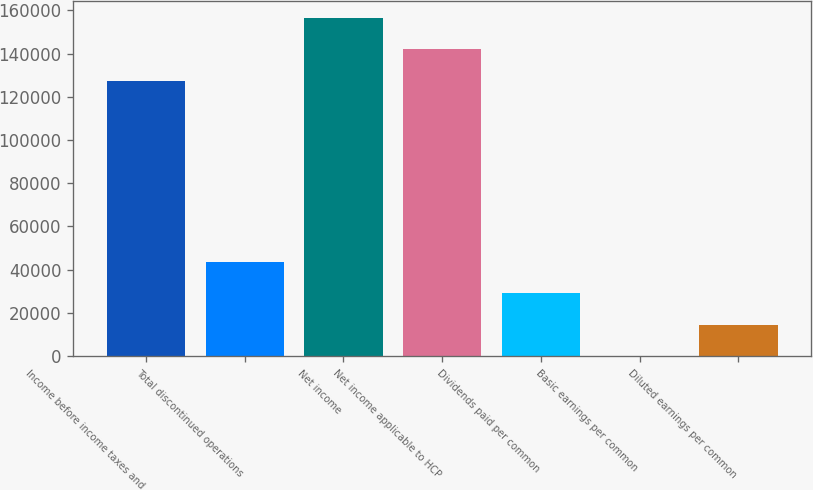<chart> <loc_0><loc_0><loc_500><loc_500><bar_chart><fcel>Income before income taxes and<fcel>Total discontinued operations<fcel>Net income<fcel>Net income applicable to HCP<fcel>Dividends paid per common<fcel>Basic earnings per common<fcel>Diluted earnings per common<nl><fcel>127341<fcel>43658.1<fcel>156470<fcel>141917<fcel>29105.5<fcel>0.42<fcel>14553<nl></chart> 